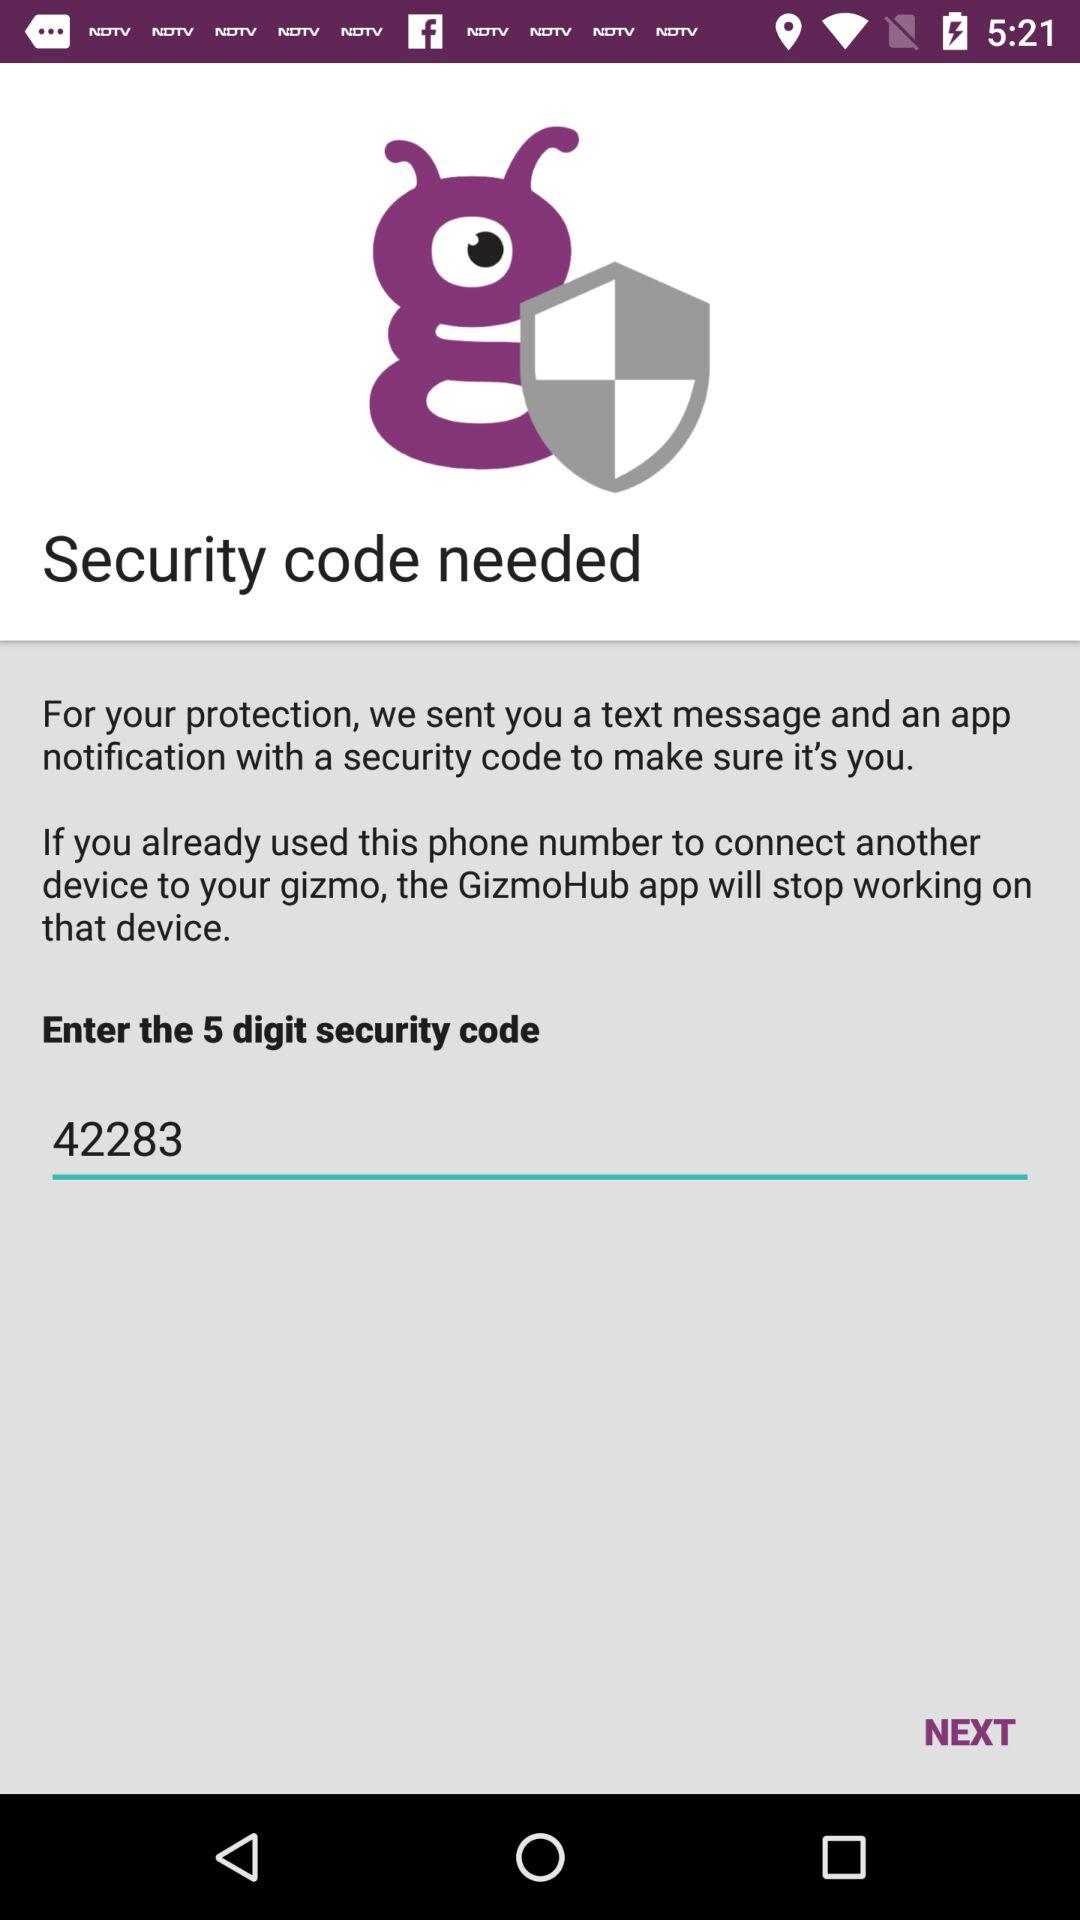How many digits does the security code have?
Answer the question using a single word or phrase. 5 